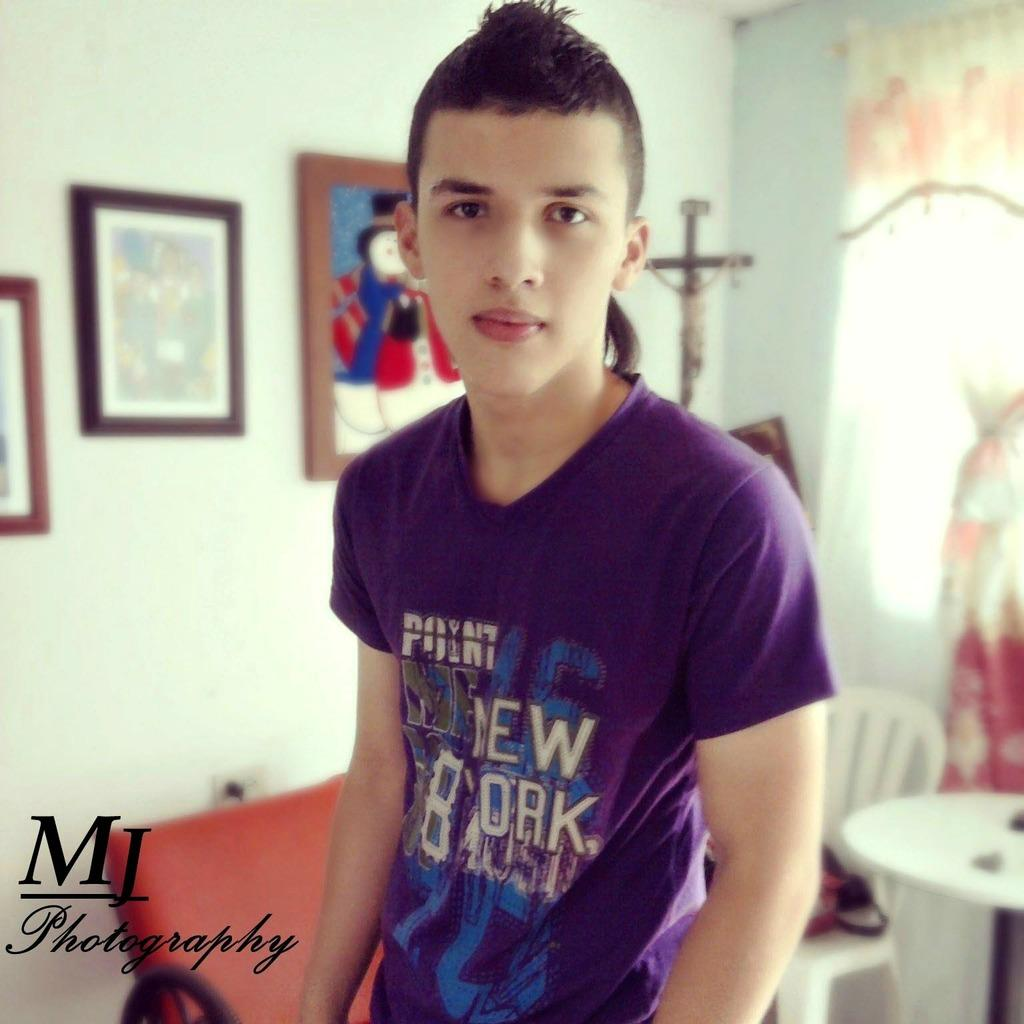What is the main subject in the image? There is a person in the image. What is the person interacting with in the image? The person is likely interacting with a table and a chair, as both are visible in the image. What can be seen in the background of the image? There are frames and a wall visible in the background of the image. How many eggs can be seen on the goat in the image? There are no eggs or goats present in the image. 